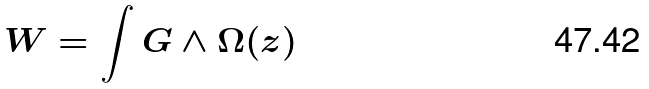Convert formula to latex. <formula><loc_0><loc_0><loc_500><loc_500>W = \int G \wedge \Omega ( z )</formula> 